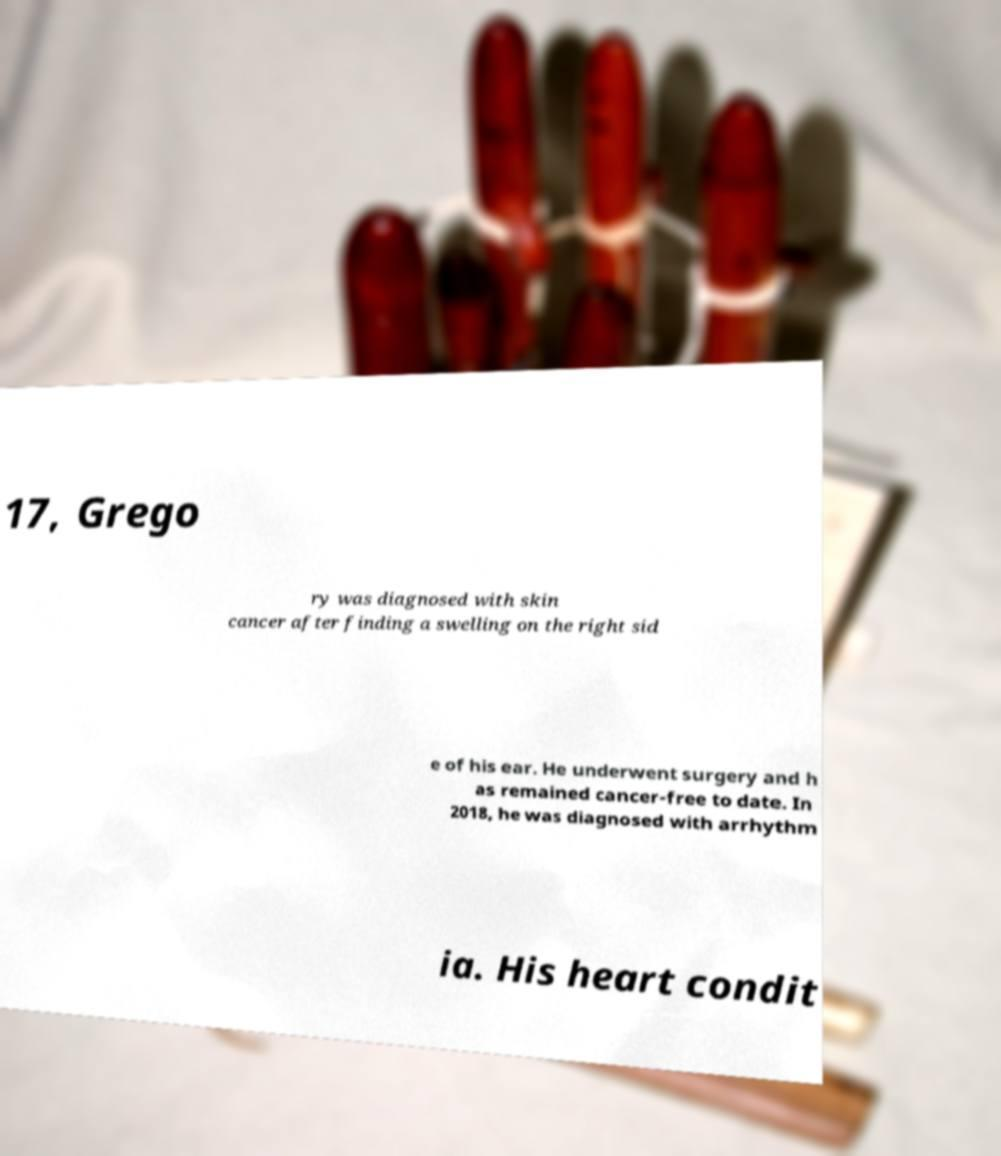What messages or text are displayed in this image? I need them in a readable, typed format. 17, Grego ry was diagnosed with skin cancer after finding a swelling on the right sid e of his ear. He underwent surgery and h as remained cancer-free to date. In 2018, he was diagnosed with arrhythm ia. His heart condit 